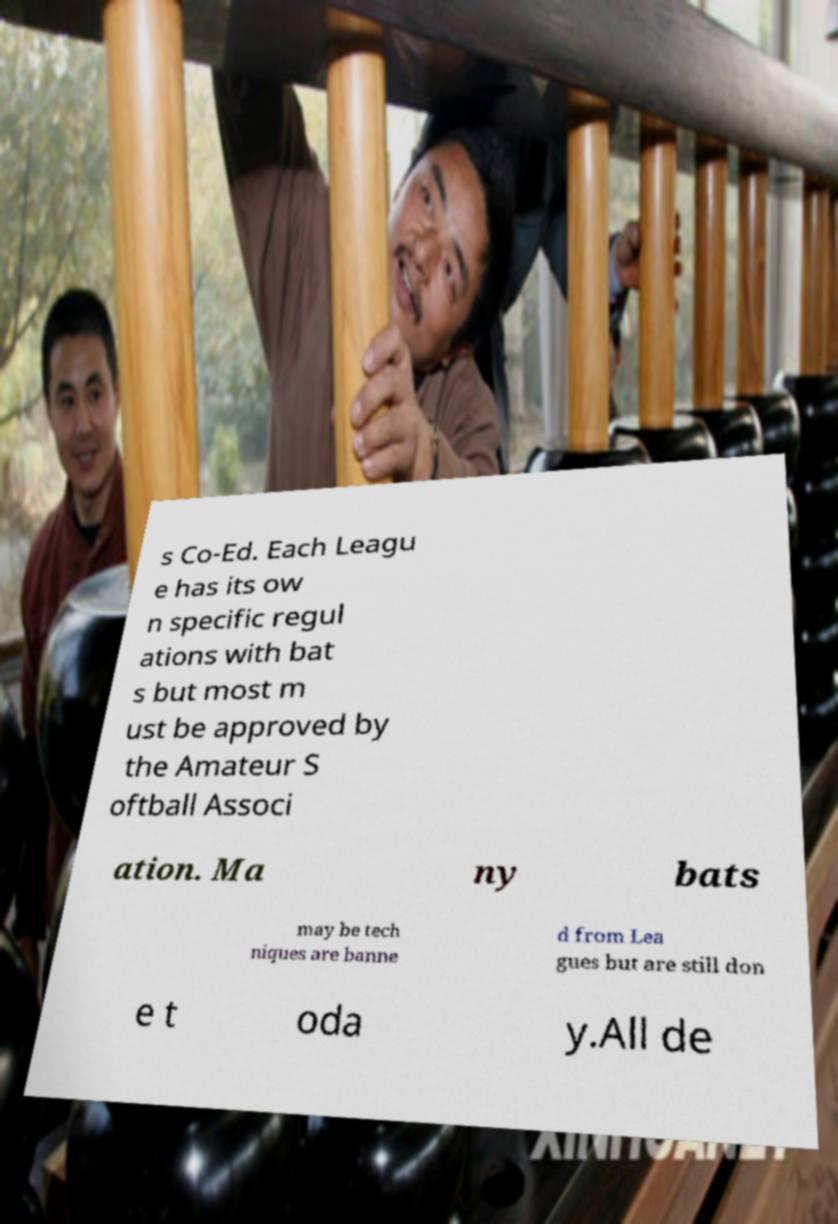Could you assist in decoding the text presented in this image and type it out clearly? s Co-Ed. Each Leagu e has its ow n specific regul ations with bat s but most m ust be approved by the Amateur S oftball Associ ation. Ma ny bats may be tech niques are banne d from Lea gues but are still don e t oda y.All de 